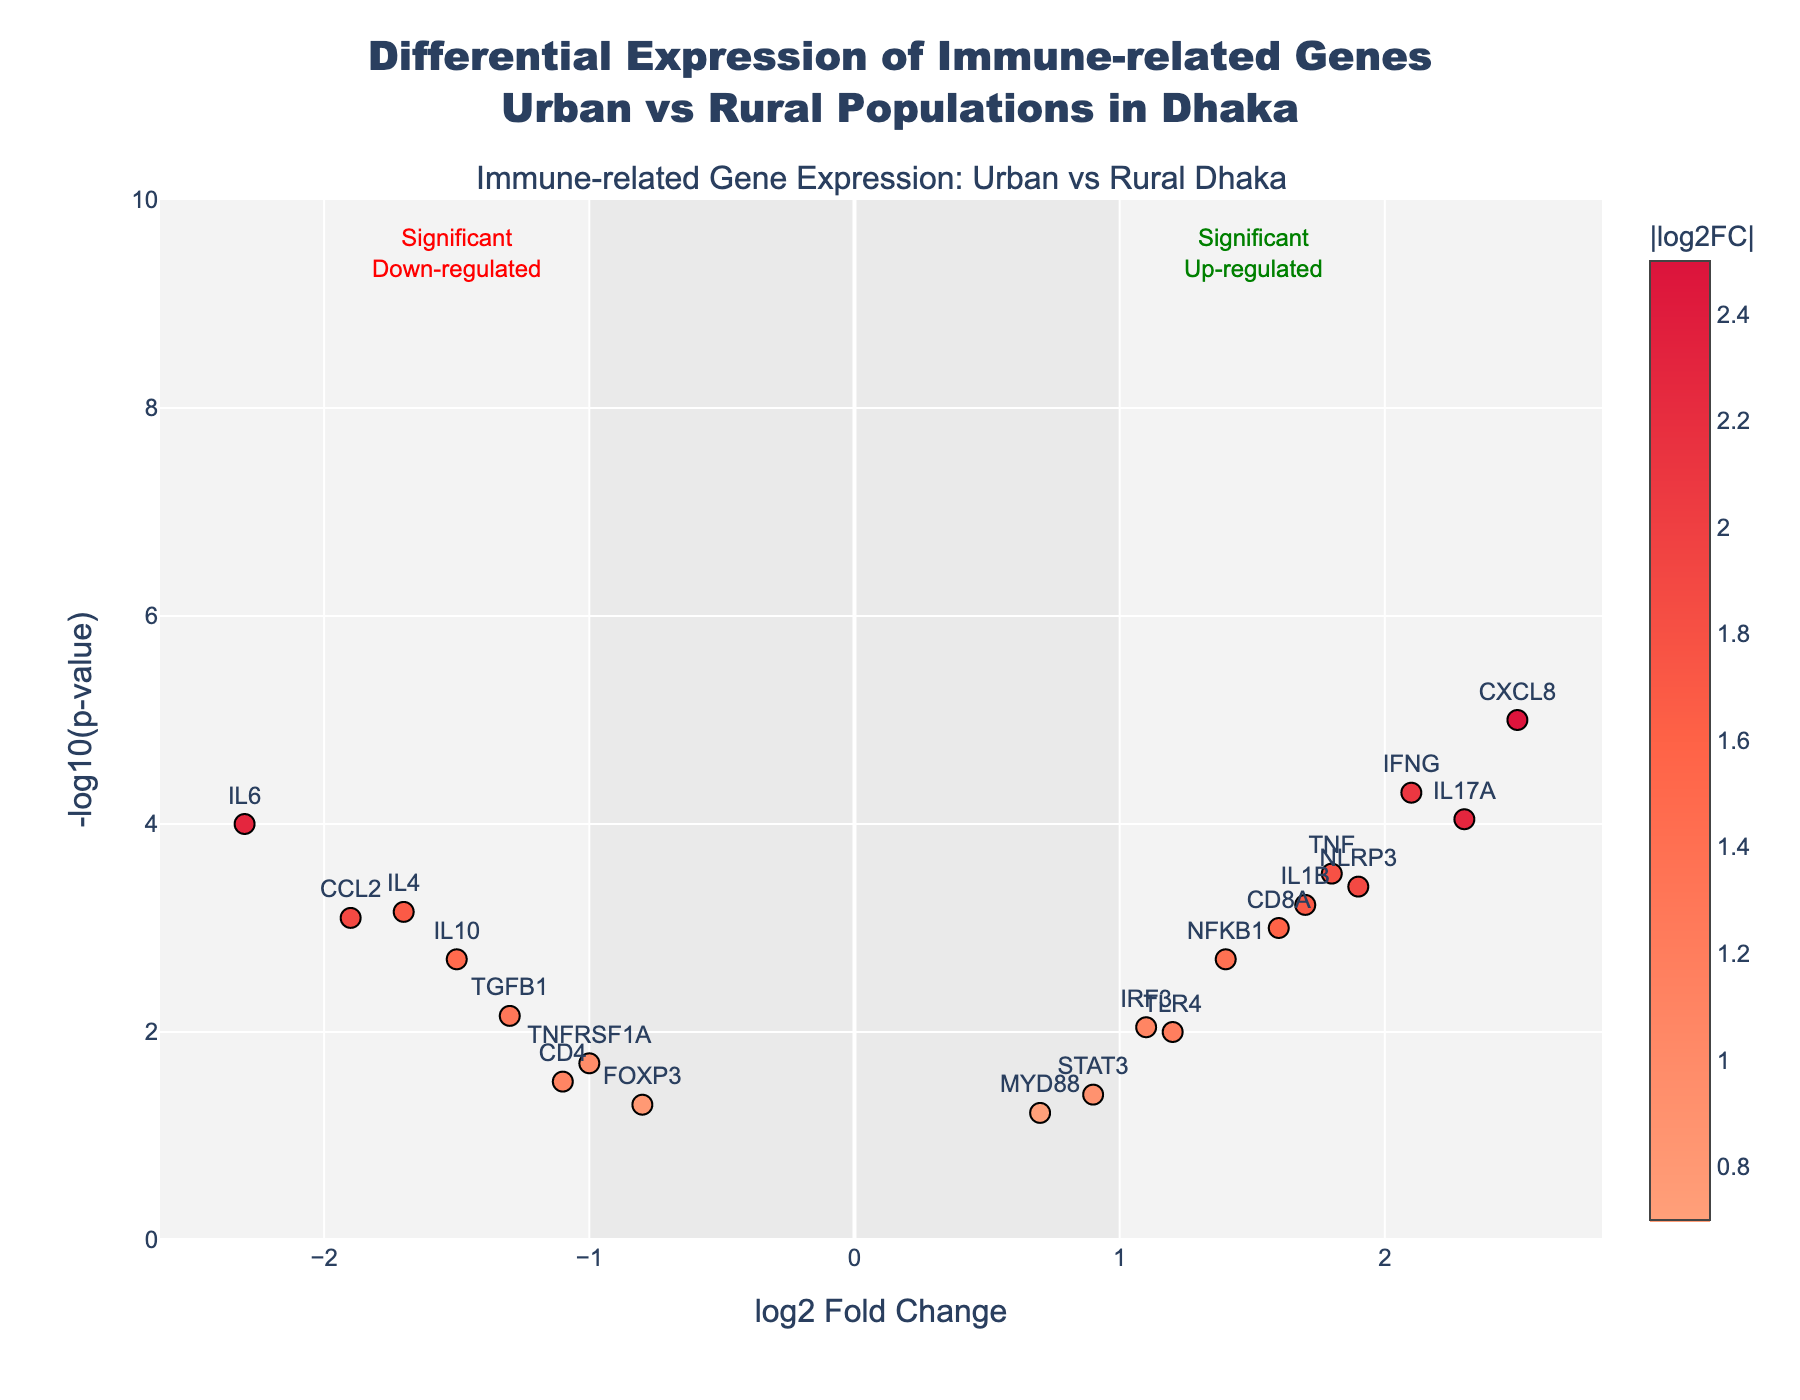How many genes are displayed in the plot? To determine the total number of genes, count the number of points on the plot. Each gene is represented by a data point with its corresponding gene name labeled.
Answer: 19 What is the title of the plot? The title is usually located at the top of the plot, providing an overview of what the plot represents.
Answer: Differential Expression of Immune-related Genes Urban vs Rural Populations in Dhaka Which gene has the highest log2 Fold Change (log2FC)? Look for the data point that is farthest to the right on the x-axis. Read the label next to that point.
Answer: CXCL8 Which gene has the lowest p-value? The p-value is represented on the y-axis as -log10(p-value). The gene with the lowest p-value will be the highest point on the plot.
Answer: CXCL8 Are any genes both significantly up-regulated and labeled with a log2FC greater than 2? To find significantly up-regulated genes, look for points in the upper right region outside the shaded area. Check their log2FC values if they are greater than 2.
Answer: Yes, CXCL8 and IL17A Which gene has the lowest log2 Fold Change (log2FC)? Look for the point farthest to the left on the x-axis. Read the label next to that point.
Answer: IL6 Which gene is closest to having no change in fold expression (log2FC close to 0)? Identify the point closest to the origin (0,0) on the x-axis, indicating minimal change in fold expression.
Answer: MYD88 What is the log2FC and p-value for TNF? Find the point labeled "TNF" on the plot. Use the hover text or axis values to read the log2FC and p-value.
Answer: log2FC: 1.8, p-value: 0.0003 Of the significantly down-regulated genes, which one is the least significant (highest p-value)? Significantly down-regulated genes are to the left, outside the shaded area. Find the one with the lowest point (highest p-value).
Answer: TGFB1 Which genes have a p-value greater than 0.01? Points with a p-value greater than 0.01 will be in the lower region of the plot (-log10(p-value) less than 2). Identify such points and their gene labels.
Answer: FOXP3, CD4, STAT3, MYD88 